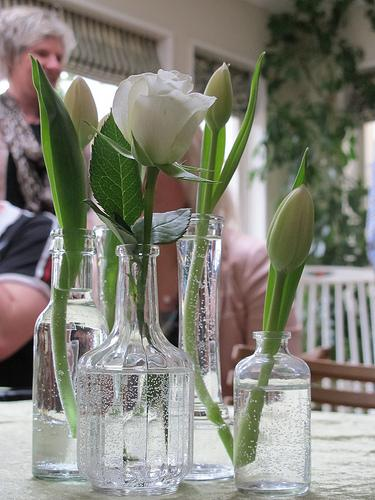Question: who is in the background?
Choices:
A. People.
B. Animals.
C. Cars.
D. Trees.
Answer with the letter. Answer: A Question: how many open flowers?
Choices:
A. 2.
B. 1.
C. 3.
D. 4.
Answer with the letter. Answer: B Question: what is in the smallest vase?
Choices:
A. Money.
B. Flower bud and water.
C. Tacks.
D. Hair.
Answer with the letter. Answer: B Question: what color are the leaves?
Choices:
A. Green.
B. Brown.
C. Black.
D. Yellow.
Answer with the letter. Answer: A 